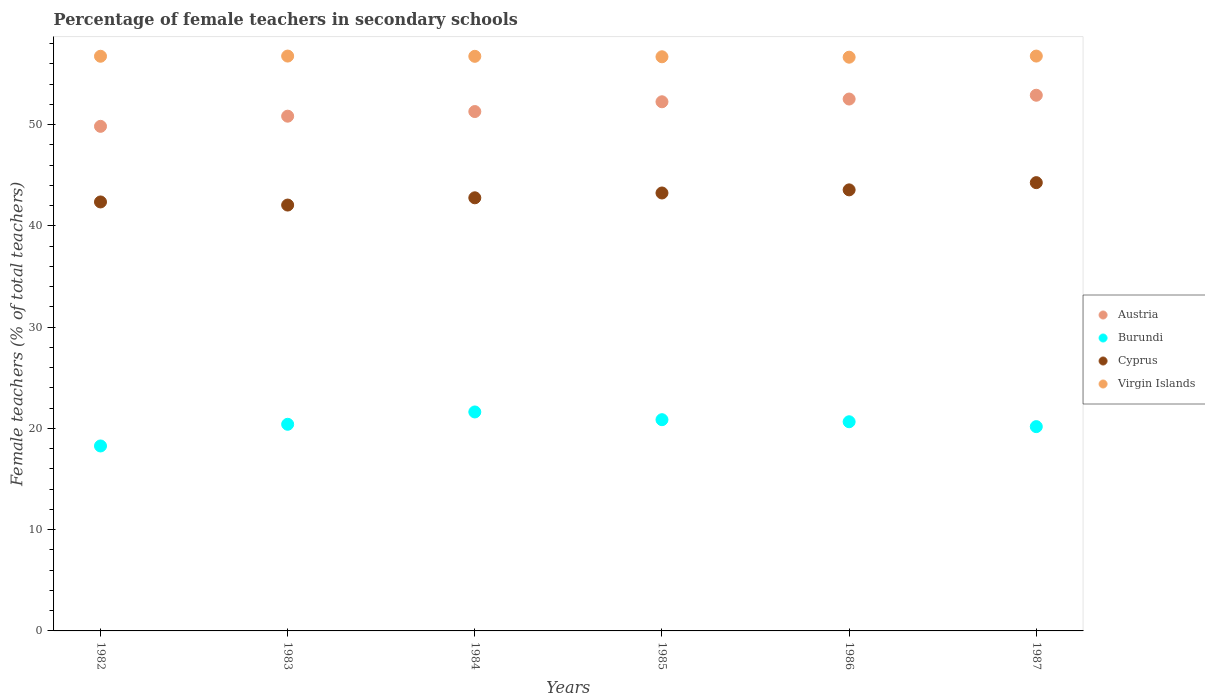Is the number of dotlines equal to the number of legend labels?
Offer a very short reply. Yes. What is the percentage of female teachers in Cyprus in 1983?
Offer a very short reply. 42.06. Across all years, what is the maximum percentage of female teachers in Austria?
Offer a terse response. 52.91. Across all years, what is the minimum percentage of female teachers in Austria?
Your answer should be very brief. 49.84. In which year was the percentage of female teachers in Cyprus minimum?
Your response must be concise. 1983. What is the total percentage of female teachers in Virgin Islands in the graph?
Make the answer very short. 340.45. What is the difference between the percentage of female teachers in Burundi in 1985 and that in 1987?
Your response must be concise. 0.69. What is the difference between the percentage of female teachers in Cyprus in 1986 and the percentage of female teachers in Virgin Islands in 1982?
Provide a succinct answer. -13.2. What is the average percentage of female teachers in Cyprus per year?
Ensure brevity in your answer.  43.05. In the year 1983, what is the difference between the percentage of female teachers in Burundi and percentage of female teachers in Austria?
Keep it short and to the point. -30.43. In how many years, is the percentage of female teachers in Virgin Islands greater than 54 %?
Give a very brief answer. 6. What is the difference between the highest and the second highest percentage of female teachers in Burundi?
Make the answer very short. 0.76. What is the difference between the highest and the lowest percentage of female teachers in Cyprus?
Your answer should be very brief. 2.21. In how many years, is the percentage of female teachers in Virgin Islands greater than the average percentage of female teachers in Virgin Islands taken over all years?
Give a very brief answer. 4. Is the sum of the percentage of female teachers in Austria in 1982 and 1983 greater than the maximum percentage of female teachers in Burundi across all years?
Offer a terse response. Yes. Is it the case that in every year, the sum of the percentage of female teachers in Austria and percentage of female teachers in Virgin Islands  is greater than the sum of percentage of female teachers in Burundi and percentage of female teachers in Cyprus?
Offer a very short reply. Yes. Does the percentage of female teachers in Cyprus monotonically increase over the years?
Offer a terse response. No. How many dotlines are there?
Provide a succinct answer. 4. How many years are there in the graph?
Your answer should be very brief. 6. What is the difference between two consecutive major ticks on the Y-axis?
Your answer should be compact. 10. Are the values on the major ticks of Y-axis written in scientific E-notation?
Your answer should be compact. No. Does the graph contain any zero values?
Offer a very short reply. No. Does the graph contain grids?
Offer a terse response. No. How many legend labels are there?
Your answer should be compact. 4. How are the legend labels stacked?
Give a very brief answer. Vertical. What is the title of the graph?
Your answer should be very brief. Percentage of female teachers in secondary schools. Does "Norway" appear as one of the legend labels in the graph?
Your answer should be very brief. No. What is the label or title of the Y-axis?
Provide a short and direct response. Female teachers (% of total teachers). What is the Female teachers (% of total teachers) in Austria in 1982?
Your answer should be very brief. 49.84. What is the Female teachers (% of total teachers) in Burundi in 1982?
Offer a very short reply. 18.27. What is the Female teachers (% of total teachers) in Cyprus in 1982?
Your answer should be compact. 42.37. What is the Female teachers (% of total teachers) in Virgin Islands in 1982?
Provide a short and direct response. 56.76. What is the Female teachers (% of total teachers) of Austria in 1983?
Give a very brief answer. 50.84. What is the Female teachers (% of total teachers) of Burundi in 1983?
Make the answer very short. 20.41. What is the Female teachers (% of total teachers) of Cyprus in 1983?
Offer a terse response. 42.06. What is the Female teachers (% of total teachers) in Virgin Islands in 1983?
Keep it short and to the point. 56.78. What is the Female teachers (% of total teachers) in Austria in 1984?
Ensure brevity in your answer.  51.3. What is the Female teachers (% of total teachers) of Burundi in 1984?
Your response must be concise. 21.63. What is the Female teachers (% of total teachers) in Cyprus in 1984?
Make the answer very short. 42.78. What is the Female teachers (% of total teachers) in Virgin Islands in 1984?
Offer a very short reply. 56.75. What is the Female teachers (% of total teachers) in Austria in 1985?
Ensure brevity in your answer.  52.26. What is the Female teachers (% of total teachers) in Burundi in 1985?
Give a very brief answer. 20.86. What is the Female teachers (% of total teachers) in Cyprus in 1985?
Offer a very short reply. 43.26. What is the Female teachers (% of total teachers) in Virgin Islands in 1985?
Offer a very short reply. 56.71. What is the Female teachers (% of total teachers) of Austria in 1986?
Make the answer very short. 52.53. What is the Female teachers (% of total teachers) in Burundi in 1986?
Provide a succinct answer. 20.66. What is the Female teachers (% of total teachers) in Cyprus in 1986?
Make the answer very short. 43.56. What is the Female teachers (% of total teachers) of Virgin Islands in 1986?
Keep it short and to the point. 56.67. What is the Female teachers (% of total teachers) of Austria in 1987?
Provide a succinct answer. 52.91. What is the Female teachers (% of total teachers) in Burundi in 1987?
Make the answer very short. 20.18. What is the Female teachers (% of total teachers) in Cyprus in 1987?
Provide a succinct answer. 44.28. What is the Female teachers (% of total teachers) in Virgin Islands in 1987?
Your answer should be compact. 56.78. Across all years, what is the maximum Female teachers (% of total teachers) of Austria?
Offer a terse response. 52.91. Across all years, what is the maximum Female teachers (% of total teachers) of Burundi?
Offer a terse response. 21.63. Across all years, what is the maximum Female teachers (% of total teachers) of Cyprus?
Offer a very short reply. 44.28. Across all years, what is the maximum Female teachers (% of total teachers) of Virgin Islands?
Your answer should be very brief. 56.78. Across all years, what is the minimum Female teachers (% of total teachers) in Austria?
Your answer should be very brief. 49.84. Across all years, what is the minimum Female teachers (% of total teachers) of Burundi?
Give a very brief answer. 18.27. Across all years, what is the minimum Female teachers (% of total teachers) of Cyprus?
Ensure brevity in your answer.  42.06. Across all years, what is the minimum Female teachers (% of total teachers) in Virgin Islands?
Your answer should be compact. 56.67. What is the total Female teachers (% of total teachers) of Austria in the graph?
Keep it short and to the point. 309.69. What is the total Female teachers (% of total teachers) of Burundi in the graph?
Your answer should be very brief. 122.01. What is the total Female teachers (% of total teachers) of Cyprus in the graph?
Keep it short and to the point. 258.31. What is the total Female teachers (% of total teachers) of Virgin Islands in the graph?
Provide a succinct answer. 340.45. What is the difference between the Female teachers (% of total teachers) of Austria in 1982 and that in 1983?
Ensure brevity in your answer.  -1. What is the difference between the Female teachers (% of total teachers) of Burundi in 1982 and that in 1983?
Your answer should be very brief. -2.14. What is the difference between the Female teachers (% of total teachers) in Cyprus in 1982 and that in 1983?
Keep it short and to the point. 0.31. What is the difference between the Female teachers (% of total teachers) of Virgin Islands in 1982 and that in 1983?
Offer a terse response. -0.02. What is the difference between the Female teachers (% of total teachers) of Austria in 1982 and that in 1984?
Your answer should be very brief. -1.46. What is the difference between the Female teachers (% of total teachers) in Burundi in 1982 and that in 1984?
Your response must be concise. -3.36. What is the difference between the Female teachers (% of total teachers) of Cyprus in 1982 and that in 1984?
Ensure brevity in your answer.  -0.41. What is the difference between the Female teachers (% of total teachers) in Virgin Islands in 1982 and that in 1984?
Ensure brevity in your answer.  0.01. What is the difference between the Female teachers (% of total teachers) of Austria in 1982 and that in 1985?
Provide a succinct answer. -2.43. What is the difference between the Female teachers (% of total teachers) of Burundi in 1982 and that in 1985?
Provide a short and direct response. -2.6. What is the difference between the Female teachers (% of total teachers) of Cyprus in 1982 and that in 1985?
Make the answer very short. -0.89. What is the difference between the Female teachers (% of total teachers) of Virgin Islands in 1982 and that in 1985?
Offer a terse response. 0.05. What is the difference between the Female teachers (% of total teachers) in Austria in 1982 and that in 1986?
Ensure brevity in your answer.  -2.7. What is the difference between the Female teachers (% of total teachers) of Burundi in 1982 and that in 1986?
Your answer should be very brief. -2.39. What is the difference between the Female teachers (% of total teachers) in Cyprus in 1982 and that in 1986?
Your answer should be very brief. -1.19. What is the difference between the Female teachers (% of total teachers) in Virgin Islands in 1982 and that in 1986?
Provide a succinct answer. 0.09. What is the difference between the Female teachers (% of total teachers) in Austria in 1982 and that in 1987?
Your answer should be compact. -3.07. What is the difference between the Female teachers (% of total teachers) in Burundi in 1982 and that in 1987?
Your response must be concise. -1.91. What is the difference between the Female teachers (% of total teachers) of Cyprus in 1982 and that in 1987?
Make the answer very short. -1.91. What is the difference between the Female teachers (% of total teachers) in Virgin Islands in 1982 and that in 1987?
Offer a very short reply. -0.02. What is the difference between the Female teachers (% of total teachers) of Austria in 1983 and that in 1984?
Your answer should be compact. -0.46. What is the difference between the Female teachers (% of total teachers) in Burundi in 1983 and that in 1984?
Ensure brevity in your answer.  -1.22. What is the difference between the Female teachers (% of total teachers) in Cyprus in 1983 and that in 1984?
Give a very brief answer. -0.72. What is the difference between the Female teachers (% of total teachers) of Virgin Islands in 1983 and that in 1984?
Provide a succinct answer. 0.03. What is the difference between the Female teachers (% of total teachers) of Austria in 1983 and that in 1985?
Provide a short and direct response. -1.42. What is the difference between the Female teachers (% of total teachers) in Burundi in 1983 and that in 1985?
Provide a short and direct response. -0.45. What is the difference between the Female teachers (% of total teachers) of Cyprus in 1983 and that in 1985?
Ensure brevity in your answer.  -1.19. What is the difference between the Female teachers (% of total teachers) of Virgin Islands in 1983 and that in 1985?
Your answer should be compact. 0.07. What is the difference between the Female teachers (% of total teachers) of Austria in 1983 and that in 1986?
Keep it short and to the point. -1.69. What is the difference between the Female teachers (% of total teachers) in Cyprus in 1983 and that in 1986?
Give a very brief answer. -1.5. What is the difference between the Female teachers (% of total teachers) in Virgin Islands in 1983 and that in 1986?
Keep it short and to the point. 0.11. What is the difference between the Female teachers (% of total teachers) of Austria in 1983 and that in 1987?
Keep it short and to the point. -2.07. What is the difference between the Female teachers (% of total teachers) in Burundi in 1983 and that in 1987?
Your response must be concise. 0.23. What is the difference between the Female teachers (% of total teachers) in Cyprus in 1983 and that in 1987?
Keep it short and to the point. -2.21. What is the difference between the Female teachers (% of total teachers) in Virgin Islands in 1983 and that in 1987?
Provide a succinct answer. 0. What is the difference between the Female teachers (% of total teachers) in Austria in 1984 and that in 1985?
Ensure brevity in your answer.  -0.96. What is the difference between the Female teachers (% of total teachers) of Burundi in 1984 and that in 1985?
Make the answer very short. 0.76. What is the difference between the Female teachers (% of total teachers) in Cyprus in 1984 and that in 1985?
Keep it short and to the point. -0.48. What is the difference between the Female teachers (% of total teachers) of Virgin Islands in 1984 and that in 1985?
Offer a terse response. 0.04. What is the difference between the Female teachers (% of total teachers) of Austria in 1984 and that in 1986?
Make the answer very short. -1.24. What is the difference between the Female teachers (% of total teachers) of Burundi in 1984 and that in 1986?
Provide a succinct answer. 0.97. What is the difference between the Female teachers (% of total teachers) of Cyprus in 1984 and that in 1986?
Provide a succinct answer. -0.78. What is the difference between the Female teachers (% of total teachers) in Virgin Islands in 1984 and that in 1986?
Provide a succinct answer. 0.09. What is the difference between the Female teachers (% of total teachers) in Austria in 1984 and that in 1987?
Make the answer very short. -1.61. What is the difference between the Female teachers (% of total teachers) of Burundi in 1984 and that in 1987?
Make the answer very short. 1.45. What is the difference between the Female teachers (% of total teachers) in Cyprus in 1984 and that in 1987?
Your answer should be compact. -1.5. What is the difference between the Female teachers (% of total teachers) in Virgin Islands in 1984 and that in 1987?
Give a very brief answer. -0.03. What is the difference between the Female teachers (% of total teachers) in Austria in 1985 and that in 1986?
Your answer should be very brief. -0.27. What is the difference between the Female teachers (% of total teachers) of Burundi in 1985 and that in 1986?
Provide a short and direct response. 0.2. What is the difference between the Female teachers (% of total teachers) in Cyprus in 1985 and that in 1986?
Provide a short and direct response. -0.31. What is the difference between the Female teachers (% of total teachers) of Virgin Islands in 1985 and that in 1986?
Give a very brief answer. 0.04. What is the difference between the Female teachers (% of total teachers) of Austria in 1985 and that in 1987?
Ensure brevity in your answer.  -0.65. What is the difference between the Female teachers (% of total teachers) of Burundi in 1985 and that in 1987?
Make the answer very short. 0.69. What is the difference between the Female teachers (% of total teachers) in Cyprus in 1985 and that in 1987?
Make the answer very short. -1.02. What is the difference between the Female teachers (% of total teachers) in Virgin Islands in 1985 and that in 1987?
Your answer should be compact. -0.07. What is the difference between the Female teachers (% of total teachers) of Austria in 1986 and that in 1987?
Give a very brief answer. -0.38. What is the difference between the Female teachers (% of total teachers) of Burundi in 1986 and that in 1987?
Ensure brevity in your answer.  0.48. What is the difference between the Female teachers (% of total teachers) in Cyprus in 1986 and that in 1987?
Your answer should be compact. -0.71. What is the difference between the Female teachers (% of total teachers) of Virgin Islands in 1986 and that in 1987?
Ensure brevity in your answer.  -0.11. What is the difference between the Female teachers (% of total teachers) of Austria in 1982 and the Female teachers (% of total teachers) of Burundi in 1983?
Make the answer very short. 29.43. What is the difference between the Female teachers (% of total teachers) of Austria in 1982 and the Female teachers (% of total teachers) of Cyprus in 1983?
Your response must be concise. 7.78. What is the difference between the Female teachers (% of total teachers) of Austria in 1982 and the Female teachers (% of total teachers) of Virgin Islands in 1983?
Ensure brevity in your answer.  -6.94. What is the difference between the Female teachers (% of total teachers) in Burundi in 1982 and the Female teachers (% of total teachers) in Cyprus in 1983?
Give a very brief answer. -23.79. What is the difference between the Female teachers (% of total teachers) of Burundi in 1982 and the Female teachers (% of total teachers) of Virgin Islands in 1983?
Make the answer very short. -38.51. What is the difference between the Female teachers (% of total teachers) in Cyprus in 1982 and the Female teachers (% of total teachers) in Virgin Islands in 1983?
Offer a very short reply. -14.41. What is the difference between the Female teachers (% of total teachers) in Austria in 1982 and the Female teachers (% of total teachers) in Burundi in 1984?
Offer a terse response. 28.21. What is the difference between the Female teachers (% of total teachers) of Austria in 1982 and the Female teachers (% of total teachers) of Cyprus in 1984?
Provide a succinct answer. 7.06. What is the difference between the Female teachers (% of total teachers) in Austria in 1982 and the Female teachers (% of total teachers) in Virgin Islands in 1984?
Provide a succinct answer. -6.92. What is the difference between the Female teachers (% of total teachers) of Burundi in 1982 and the Female teachers (% of total teachers) of Cyprus in 1984?
Offer a terse response. -24.51. What is the difference between the Female teachers (% of total teachers) in Burundi in 1982 and the Female teachers (% of total teachers) in Virgin Islands in 1984?
Make the answer very short. -38.48. What is the difference between the Female teachers (% of total teachers) of Cyprus in 1982 and the Female teachers (% of total teachers) of Virgin Islands in 1984?
Offer a very short reply. -14.38. What is the difference between the Female teachers (% of total teachers) in Austria in 1982 and the Female teachers (% of total teachers) in Burundi in 1985?
Offer a terse response. 28.97. What is the difference between the Female teachers (% of total teachers) of Austria in 1982 and the Female teachers (% of total teachers) of Cyprus in 1985?
Give a very brief answer. 6.58. What is the difference between the Female teachers (% of total teachers) of Austria in 1982 and the Female teachers (% of total teachers) of Virgin Islands in 1985?
Keep it short and to the point. -6.87. What is the difference between the Female teachers (% of total teachers) in Burundi in 1982 and the Female teachers (% of total teachers) in Cyprus in 1985?
Ensure brevity in your answer.  -24.99. What is the difference between the Female teachers (% of total teachers) in Burundi in 1982 and the Female teachers (% of total teachers) in Virgin Islands in 1985?
Make the answer very short. -38.44. What is the difference between the Female teachers (% of total teachers) of Cyprus in 1982 and the Female teachers (% of total teachers) of Virgin Islands in 1985?
Offer a terse response. -14.34. What is the difference between the Female teachers (% of total teachers) in Austria in 1982 and the Female teachers (% of total teachers) in Burundi in 1986?
Your answer should be very brief. 29.18. What is the difference between the Female teachers (% of total teachers) in Austria in 1982 and the Female teachers (% of total teachers) in Cyprus in 1986?
Ensure brevity in your answer.  6.28. What is the difference between the Female teachers (% of total teachers) of Austria in 1982 and the Female teachers (% of total teachers) of Virgin Islands in 1986?
Offer a very short reply. -6.83. What is the difference between the Female teachers (% of total teachers) in Burundi in 1982 and the Female teachers (% of total teachers) in Cyprus in 1986?
Offer a very short reply. -25.29. What is the difference between the Female teachers (% of total teachers) of Burundi in 1982 and the Female teachers (% of total teachers) of Virgin Islands in 1986?
Offer a very short reply. -38.4. What is the difference between the Female teachers (% of total teachers) of Cyprus in 1982 and the Female teachers (% of total teachers) of Virgin Islands in 1986?
Offer a very short reply. -14.3. What is the difference between the Female teachers (% of total teachers) of Austria in 1982 and the Female teachers (% of total teachers) of Burundi in 1987?
Keep it short and to the point. 29.66. What is the difference between the Female teachers (% of total teachers) of Austria in 1982 and the Female teachers (% of total teachers) of Cyprus in 1987?
Your answer should be very brief. 5.56. What is the difference between the Female teachers (% of total teachers) in Austria in 1982 and the Female teachers (% of total teachers) in Virgin Islands in 1987?
Provide a short and direct response. -6.94. What is the difference between the Female teachers (% of total teachers) in Burundi in 1982 and the Female teachers (% of total teachers) in Cyprus in 1987?
Offer a terse response. -26.01. What is the difference between the Female teachers (% of total teachers) of Burundi in 1982 and the Female teachers (% of total teachers) of Virgin Islands in 1987?
Provide a succinct answer. -38.51. What is the difference between the Female teachers (% of total teachers) of Cyprus in 1982 and the Female teachers (% of total teachers) of Virgin Islands in 1987?
Provide a short and direct response. -14.41. What is the difference between the Female teachers (% of total teachers) of Austria in 1983 and the Female teachers (% of total teachers) of Burundi in 1984?
Ensure brevity in your answer.  29.21. What is the difference between the Female teachers (% of total teachers) in Austria in 1983 and the Female teachers (% of total teachers) in Cyprus in 1984?
Your answer should be compact. 8.06. What is the difference between the Female teachers (% of total teachers) of Austria in 1983 and the Female teachers (% of total teachers) of Virgin Islands in 1984?
Provide a succinct answer. -5.91. What is the difference between the Female teachers (% of total teachers) in Burundi in 1983 and the Female teachers (% of total teachers) in Cyprus in 1984?
Ensure brevity in your answer.  -22.37. What is the difference between the Female teachers (% of total teachers) of Burundi in 1983 and the Female teachers (% of total teachers) of Virgin Islands in 1984?
Offer a terse response. -36.34. What is the difference between the Female teachers (% of total teachers) in Cyprus in 1983 and the Female teachers (% of total teachers) in Virgin Islands in 1984?
Your answer should be very brief. -14.69. What is the difference between the Female teachers (% of total teachers) of Austria in 1983 and the Female teachers (% of total teachers) of Burundi in 1985?
Provide a succinct answer. 29.98. What is the difference between the Female teachers (% of total teachers) in Austria in 1983 and the Female teachers (% of total teachers) in Cyprus in 1985?
Provide a succinct answer. 7.59. What is the difference between the Female teachers (% of total teachers) of Austria in 1983 and the Female teachers (% of total teachers) of Virgin Islands in 1985?
Provide a short and direct response. -5.87. What is the difference between the Female teachers (% of total teachers) in Burundi in 1983 and the Female teachers (% of total teachers) in Cyprus in 1985?
Offer a very short reply. -22.85. What is the difference between the Female teachers (% of total teachers) in Burundi in 1983 and the Female teachers (% of total teachers) in Virgin Islands in 1985?
Make the answer very short. -36.3. What is the difference between the Female teachers (% of total teachers) of Cyprus in 1983 and the Female teachers (% of total teachers) of Virgin Islands in 1985?
Offer a terse response. -14.65. What is the difference between the Female teachers (% of total teachers) in Austria in 1983 and the Female teachers (% of total teachers) in Burundi in 1986?
Offer a terse response. 30.18. What is the difference between the Female teachers (% of total teachers) in Austria in 1983 and the Female teachers (% of total teachers) in Cyprus in 1986?
Ensure brevity in your answer.  7.28. What is the difference between the Female teachers (% of total teachers) in Austria in 1983 and the Female teachers (% of total teachers) in Virgin Islands in 1986?
Provide a short and direct response. -5.83. What is the difference between the Female teachers (% of total teachers) in Burundi in 1983 and the Female teachers (% of total teachers) in Cyprus in 1986?
Keep it short and to the point. -23.15. What is the difference between the Female teachers (% of total teachers) in Burundi in 1983 and the Female teachers (% of total teachers) in Virgin Islands in 1986?
Keep it short and to the point. -36.26. What is the difference between the Female teachers (% of total teachers) of Cyprus in 1983 and the Female teachers (% of total teachers) of Virgin Islands in 1986?
Offer a very short reply. -14.6. What is the difference between the Female teachers (% of total teachers) of Austria in 1983 and the Female teachers (% of total teachers) of Burundi in 1987?
Provide a succinct answer. 30.66. What is the difference between the Female teachers (% of total teachers) of Austria in 1983 and the Female teachers (% of total teachers) of Cyprus in 1987?
Provide a short and direct response. 6.56. What is the difference between the Female teachers (% of total teachers) in Austria in 1983 and the Female teachers (% of total teachers) in Virgin Islands in 1987?
Ensure brevity in your answer.  -5.94. What is the difference between the Female teachers (% of total teachers) in Burundi in 1983 and the Female teachers (% of total teachers) in Cyprus in 1987?
Offer a terse response. -23.87. What is the difference between the Female teachers (% of total teachers) of Burundi in 1983 and the Female teachers (% of total teachers) of Virgin Islands in 1987?
Your answer should be very brief. -36.37. What is the difference between the Female teachers (% of total teachers) of Cyprus in 1983 and the Female teachers (% of total teachers) of Virgin Islands in 1987?
Provide a short and direct response. -14.72. What is the difference between the Female teachers (% of total teachers) of Austria in 1984 and the Female teachers (% of total teachers) of Burundi in 1985?
Your response must be concise. 30.44. What is the difference between the Female teachers (% of total teachers) of Austria in 1984 and the Female teachers (% of total teachers) of Cyprus in 1985?
Your answer should be very brief. 8.04. What is the difference between the Female teachers (% of total teachers) in Austria in 1984 and the Female teachers (% of total teachers) in Virgin Islands in 1985?
Offer a very short reply. -5.41. What is the difference between the Female teachers (% of total teachers) in Burundi in 1984 and the Female teachers (% of total teachers) in Cyprus in 1985?
Make the answer very short. -21.63. What is the difference between the Female teachers (% of total teachers) in Burundi in 1984 and the Female teachers (% of total teachers) in Virgin Islands in 1985?
Give a very brief answer. -35.08. What is the difference between the Female teachers (% of total teachers) of Cyprus in 1984 and the Female teachers (% of total teachers) of Virgin Islands in 1985?
Offer a terse response. -13.93. What is the difference between the Female teachers (% of total teachers) in Austria in 1984 and the Female teachers (% of total teachers) in Burundi in 1986?
Your answer should be compact. 30.64. What is the difference between the Female teachers (% of total teachers) of Austria in 1984 and the Female teachers (% of total teachers) of Cyprus in 1986?
Your answer should be compact. 7.74. What is the difference between the Female teachers (% of total teachers) of Austria in 1984 and the Female teachers (% of total teachers) of Virgin Islands in 1986?
Provide a succinct answer. -5.37. What is the difference between the Female teachers (% of total teachers) in Burundi in 1984 and the Female teachers (% of total teachers) in Cyprus in 1986?
Your response must be concise. -21.94. What is the difference between the Female teachers (% of total teachers) of Burundi in 1984 and the Female teachers (% of total teachers) of Virgin Islands in 1986?
Your answer should be very brief. -35.04. What is the difference between the Female teachers (% of total teachers) in Cyprus in 1984 and the Female teachers (% of total teachers) in Virgin Islands in 1986?
Keep it short and to the point. -13.89. What is the difference between the Female teachers (% of total teachers) in Austria in 1984 and the Female teachers (% of total teachers) in Burundi in 1987?
Your response must be concise. 31.12. What is the difference between the Female teachers (% of total teachers) in Austria in 1984 and the Female teachers (% of total teachers) in Cyprus in 1987?
Offer a very short reply. 7.02. What is the difference between the Female teachers (% of total teachers) of Austria in 1984 and the Female teachers (% of total teachers) of Virgin Islands in 1987?
Your response must be concise. -5.48. What is the difference between the Female teachers (% of total teachers) of Burundi in 1984 and the Female teachers (% of total teachers) of Cyprus in 1987?
Ensure brevity in your answer.  -22.65. What is the difference between the Female teachers (% of total teachers) of Burundi in 1984 and the Female teachers (% of total teachers) of Virgin Islands in 1987?
Your answer should be compact. -35.15. What is the difference between the Female teachers (% of total teachers) of Cyprus in 1984 and the Female teachers (% of total teachers) of Virgin Islands in 1987?
Keep it short and to the point. -14. What is the difference between the Female teachers (% of total teachers) in Austria in 1985 and the Female teachers (% of total teachers) in Burundi in 1986?
Make the answer very short. 31.6. What is the difference between the Female teachers (% of total teachers) of Austria in 1985 and the Female teachers (% of total teachers) of Cyprus in 1986?
Give a very brief answer. 8.7. What is the difference between the Female teachers (% of total teachers) in Austria in 1985 and the Female teachers (% of total teachers) in Virgin Islands in 1986?
Make the answer very short. -4.4. What is the difference between the Female teachers (% of total teachers) in Burundi in 1985 and the Female teachers (% of total teachers) in Cyprus in 1986?
Your answer should be very brief. -22.7. What is the difference between the Female teachers (% of total teachers) in Burundi in 1985 and the Female teachers (% of total teachers) in Virgin Islands in 1986?
Make the answer very short. -35.8. What is the difference between the Female teachers (% of total teachers) in Cyprus in 1985 and the Female teachers (% of total teachers) in Virgin Islands in 1986?
Keep it short and to the point. -13.41. What is the difference between the Female teachers (% of total teachers) in Austria in 1985 and the Female teachers (% of total teachers) in Burundi in 1987?
Offer a terse response. 32.09. What is the difference between the Female teachers (% of total teachers) in Austria in 1985 and the Female teachers (% of total teachers) in Cyprus in 1987?
Give a very brief answer. 7.99. What is the difference between the Female teachers (% of total teachers) in Austria in 1985 and the Female teachers (% of total teachers) in Virgin Islands in 1987?
Your answer should be compact. -4.51. What is the difference between the Female teachers (% of total teachers) in Burundi in 1985 and the Female teachers (% of total teachers) in Cyprus in 1987?
Offer a very short reply. -23.41. What is the difference between the Female teachers (% of total teachers) in Burundi in 1985 and the Female teachers (% of total teachers) in Virgin Islands in 1987?
Keep it short and to the point. -35.91. What is the difference between the Female teachers (% of total teachers) of Cyprus in 1985 and the Female teachers (% of total teachers) of Virgin Islands in 1987?
Give a very brief answer. -13.52. What is the difference between the Female teachers (% of total teachers) of Austria in 1986 and the Female teachers (% of total teachers) of Burundi in 1987?
Your response must be concise. 32.36. What is the difference between the Female teachers (% of total teachers) of Austria in 1986 and the Female teachers (% of total teachers) of Cyprus in 1987?
Offer a very short reply. 8.26. What is the difference between the Female teachers (% of total teachers) in Austria in 1986 and the Female teachers (% of total teachers) in Virgin Islands in 1987?
Offer a terse response. -4.24. What is the difference between the Female teachers (% of total teachers) in Burundi in 1986 and the Female teachers (% of total teachers) in Cyprus in 1987?
Give a very brief answer. -23.62. What is the difference between the Female teachers (% of total teachers) of Burundi in 1986 and the Female teachers (% of total teachers) of Virgin Islands in 1987?
Offer a terse response. -36.12. What is the difference between the Female teachers (% of total teachers) of Cyprus in 1986 and the Female teachers (% of total teachers) of Virgin Islands in 1987?
Your answer should be compact. -13.22. What is the average Female teachers (% of total teachers) of Austria per year?
Your response must be concise. 51.61. What is the average Female teachers (% of total teachers) of Burundi per year?
Your response must be concise. 20.33. What is the average Female teachers (% of total teachers) in Cyprus per year?
Your answer should be very brief. 43.05. What is the average Female teachers (% of total teachers) of Virgin Islands per year?
Provide a succinct answer. 56.74. In the year 1982, what is the difference between the Female teachers (% of total teachers) in Austria and Female teachers (% of total teachers) in Burundi?
Provide a short and direct response. 31.57. In the year 1982, what is the difference between the Female teachers (% of total teachers) of Austria and Female teachers (% of total teachers) of Cyprus?
Your response must be concise. 7.47. In the year 1982, what is the difference between the Female teachers (% of total teachers) of Austria and Female teachers (% of total teachers) of Virgin Islands?
Ensure brevity in your answer.  -6.92. In the year 1982, what is the difference between the Female teachers (% of total teachers) in Burundi and Female teachers (% of total teachers) in Cyprus?
Your answer should be very brief. -24.1. In the year 1982, what is the difference between the Female teachers (% of total teachers) in Burundi and Female teachers (% of total teachers) in Virgin Islands?
Provide a short and direct response. -38.49. In the year 1982, what is the difference between the Female teachers (% of total teachers) in Cyprus and Female teachers (% of total teachers) in Virgin Islands?
Provide a succinct answer. -14.39. In the year 1983, what is the difference between the Female teachers (% of total teachers) in Austria and Female teachers (% of total teachers) in Burundi?
Make the answer very short. 30.43. In the year 1983, what is the difference between the Female teachers (% of total teachers) of Austria and Female teachers (% of total teachers) of Cyprus?
Your answer should be very brief. 8.78. In the year 1983, what is the difference between the Female teachers (% of total teachers) in Austria and Female teachers (% of total teachers) in Virgin Islands?
Your answer should be compact. -5.94. In the year 1983, what is the difference between the Female teachers (% of total teachers) of Burundi and Female teachers (% of total teachers) of Cyprus?
Make the answer very short. -21.65. In the year 1983, what is the difference between the Female teachers (% of total teachers) in Burundi and Female teachers (% of total teachers) in Virgin Islands?
Your response must be concise. -36.37. In the year 1983, what is the difference between the Female teachers (% of total teachers) of Cyprus and Female teachers (% of total teachers) of Virgin Islands?
Keep it short and to the point. -14.72. In the year 1984, what is the difference between the Female teachers (% of total teachers) in Austria and Female teachers (% of total teachers) in Burundi?
Provide a succinct answer. 29.67. In the year 1984, what is the difference between the Female teachers (% of total teachers) in Austria and Female teachers (% of total teachers) in Cyprus?
Ensure brevity in your answer.  8.52. In the year 1984, what is the difference between the Female teachers (% of total teachers) in Austria and Female teachers (% of total teachers) in Virgin Islands?
Offer a very short reply. -5.45. In the year 1984, what is the difference between the Female teachers (% of total teachers) of Burundi and Female teachers (% of total teachers) of Cyprus?
Give a very brief answer. -21.15. In the year 1984, what is the difference between the Female teachers (% of total teachers) of Burundi and Female teachers (% of total teachers) of Virgin Islands?
Offer a terse response. -35.13. In the year 1984, what is the difference between the Female teachers (% of total teachers) in Cyprus and Female teachers (% of total teachers) in Virgin Islands?
Provide a short and direct response. -13.97. In the year 1985, what is the difference between the Female teachers (% of total teachers) of Austria and Female teachers (% of total teachers) of Burundi?
Provide a short and direct response. 31.4. In the year 1985, what is the difference between the Female teachers (% of total teachers) in Austria and Female teachers (% of total teachers) in Cyprus?
Give a very brief answer. 9.01. In the year 1985, what is the difference between the Female teachers (% of total teachers) of Austria and Female teachers (% of total teachers) of Virgin Islands?
Your answer should be compact. -4.45. In the year 1985, what is the difference between the Female teachers (% of total teachers) in Burundi and Female teachers (% of total teachers) in Cyprus?
Keep it short and to the point. -22.39. In the year 1985, what is the difference between the Female teachers (% of total teachers) of Burundi and Female teachers (% of total teachers) of Virgin Islands?
Give a very brief answer. -35.85. In the year 1985, what is the difference between the Female teachers (% of total teachers) of Cyprus and Female teachers (% of total teachers) of Virgin Islands?
Provide a succinct answer. -13.45. In the year 1986, what is the difference between the Female teachers (% of total teachers) in Austria and Female teachers (% of total teachers) in Burundi?
Provide a succinct answer. 31.87. In the year 1986, what is the difference between the Female teachers (% of total teachers) of Austria and Female teachers (% of total teachers) of Cyprus?
Provide a short and direct response. 8.97. In the year 1986, what is the difference between the Female teachers (% of total teachers) in Austria and Female teachers (% of total teachers) in Virgin Islands?
Give a very brief answer. -4.13. In the year 1986, what is the difference between the Female teachers (% of total teachers) in Burundi and Female teachers (% of total teachers) in Cyprus?
Keep it short and to the point. -22.9. In the year 1986, what is the difference between the Female teachers (% of total teachers) in Burundi and Female teachers (% of total teachers) in Virgin Islands?
Offer a very short reply. -36.01. In the year 1986, what is the difference between the Female teachers (% of total teachers) in Cyprus and Female teachers (% of total teachers) in Virgin Islands?
Provide a short and direct response. -13.1. In the year 1987, what is the difference between the Female teachers (% of total teachers) of Austria and Female teachers (% of total teachers) of Burundi?
Provide a short and direct response. 32.73. In the year 1987, what is the difference between the Female teachers (% of total teachers) of Austria and Female teachers (% of total teachers) of Cyprus?
Provide a succinct answer. 8.63. In the year 1987, what is the difference between the Female teachers (% of total teachers) in Austria and Female teachers (% of total teachers) in Virgin Islands?
Offer a terse response. -3.87. In the year 1987, what is the difference between the Female teachers (% of total teachers) in Burundi and Female teachers (% of total teachers) in Cyprus?
Provide a succinct answer. -24.1. In the year 1987, what is the difference between the Female teachers (% of total teachers) of Burundi and Female teachers (% of total teachers) of Virgin Islands?
Keep it short and to the point. -36.6. In the year 1987, what is the difference between the Female teachers (% of total teachers) in Cyprus and Female teachers (% of total teachers) in Virgin Islands?
Keep it short and to the point. -12.5. What is the ratio of the Female teachers (% of total teachers) of Austria in 1982 to that in 1983?
Provide a short and direct response. 0.98. What is the ratio of the Female teachers (% of total teachers) in Burundi in 1982 to that in 1983?
Offer a terse response. 0.9. What is the ratio of the Female teachers (% of total teachers) in Cyprus in 1982 to that in 1983?
Keep it short and to the point. 1.01. What is the ratio of the Female teachers (% of total teachers) of Virgin Islands in 1982 to that in 1983?
Provide a succinct answer. 1. What is the ratio of the Female teachers (% of total teachers) of Austria in 1982 to that in 1984?
Your answer should be compact. 0.97. What is the ratio of the Female teachers (% of total teachers) in Burundi in 1982 to that in 1984?
Your answer should be compact. 0.84. What is the ratio of the Female teachers (% of total teachers) of Virgin Islands in 1982 to that in 1984?
Your answer should be very brief. 1. What is the ratio of the Female teachers (% of total teachers) of Austria in 1982 to that in 1985?
Your answer should be compact. 0.95. What is the ratio of the Female teachers (% of total teachers) in Burundi in 1982 to that in 1985?
Ensure brevity in your answer.  0.88. What is the ratio of the Female teachers (% of total teachers) in Cyprus in 1982 to that in 1985?
Provide a succinct answer. 0.98. What is the ratio of the Female teachers (% of total teachers) of Austria in 1982 to that in 1986?
Keep it short and to the point. 0.95. What is the ratio of the Female teachers (% of total teachers) of Burundi in 1982 to that in 1986?
Keep it short and to the point. 0.88. What is the ratio of the Female teachers (% of total teachers) of Cyprus in 1982 to that in 1986?
Make the answer very short. 0.97. What is the ratio of the Female teachers (% of total teachers) in Austria in 1982 to that in 1987?
Give a very brief answer. 0.94. What is the ratio of the Female teachers (% of total teachers) in Burundi in 1982 to that in 1987?
Provide a succinct answer. 0.91. What is the ratio of the Female teachers (% of total teachers) in Cyprus in 1982 to that in 1987?
Provide a succinct answer. 0.96. What is the ratio of the Female teachers (% of total teachers) in Burundi in 1983 to that in 1984?
Your answer should be compact. 0.94. What is the ratio of the Female teachers (% of total teachers) in Cyprus in 1983 to that in 1984?
Provide a short and direct response. 0.98. What is the ratio of the Female teachers (% of total teachers) of Austria in 1983 to that in 1985?
Keep it short and to the point. 0.97. What is the ratio of the Female teachers (% of total teachers) of Burundi in 1983 to that in 1985?
Keep it short and to the point. 0.98. What is the ratio of the Female teachers (% of total teachers) of Cyprus in 1983 to that in 1985?
Your answer should be compact. 0.97. What is the ratio of the Female teachers (% of total teachers) of Austria in 1983 to that in 1986?
Provide a succinct answer. 0.97. What is the ratio of the Female teachers (% of total teachers) in Burundi in 1983 to that in 1986?
Ensure brevity in your answer.  0.99. What is the ratio of the Female teachers (% of total teachers) in Cyprus in 1983 to that in 1986?
Ensure brevity in your answer.  0.97. What is the ratio of the Female teachers (% of total teachers) of Virgin Islands in 1983 to that in 1986?
Your response must be concise. 1. What is the ratio of the Female teachers (% of total teachers) of Austria in 1983 to that in 1987?
Ensure brevity in your answer.  0.96. What is the ratio of the Female teachers (% of total teachers) in Burundi in 1983 to that in 1987?
Make the answer very short. 1.01. What is the ratio of the Female teachers (% of total teachers) in Austria in 1984 to that in 1985?
Offer a very short reply. 0.98. What is the ratio of the Female teachers (% of total teachers) of Burundi in 1984 to that in 1985?
Offer a very short reply. 1.04. What is the ratio of the Female teachers (% of total teachers) in Cyprus in 1984 to that in 1985?
Keep it short and to the point. 0.99. What is the ratio of the Female teachers (% of total teachers) of Virgin Islands in 1984 to that in 1985?
Offer a very short reply. 1. What is the ratio of the Female teachers (% of total teachers) in Austria in 1984 to that in 1986?
Your answer should be compact. 0.98. What is the ratio of the Female teachers (% of total teachers) in Burundi in 1984 to that in 1986?
Offer a very short reply. 1.05. What is the ratio of the Female teachers (% of total teachers) of Virgin Islands in 1984 to that in 1986?
Offer a very short reply. 1. What is the ratio of the Female teachers (% of total teachers) in Austria in 1984 to that in 1987?
Your answer should be compact. 0.97. What is the ratio of the Female teachers (% of total teachers) of Burundi in 1984 to that in 1987?
Provide a succinct answer. 1.07. What is the ratio of the Female teachers (% of total teachers) of Cyprus in 1984 to that in 1987?
Keep it short and to the point. 0.97. What is the ratio of the Female teachers (% of total teachers) of Virgin Islands in 1984 to that in 1987?
Offer a terse response. 1. What is the ratio of the Female teachers (% of total teachers) in Austria in 1985 to that in 1986?
Your response must be concise. 0.99. What is the ratio of the Female teachers (% of total teachers) of Burundi in 1985 to that in 1986?
Provide a short and direct response. 1.01. What is the ratio of the Female teachers (% of total teachers) of Cyprus in 1985 to that in 1986?
Provide a succinct answer. 0.99. What is the ratio of the Female teachers (% of total teachers) in Virgin Islands in 1985 to that in 1986?
Ensure brevity in your answer.  1. What is the ratio of the Female teachers (% of total teachers) of Austria in 1985 to that in 1987?
Give a very brief answer. 0.99. What is the ratio of the Female teachers (% of total teachers) in Burundi in 1985 to that in 1987?
Your answer should be very brief. 1.03. What is the ratio of the Female teachers (% of total teachers) in Cyprus in 1985 to that in 1987?
Make the answer very short. 0.98. What is the ratio of the Female teachers (% of total teachers) in Austria in 1986 to that in 1987?
Your answer should be compact. 0.99. What is the ratio of the Female teachers (% of total teachers) in Burundi in 1986 to that in 1987?
Ensure brevity in your answer.  1.02. What is the ratio of the Female teachers (% of total teachers) of Cyprus in 1986 to that in 1987?
Give a very brief answer. 0.98. What is the difference between the highest and the second highest Female teachers (% of total teachers) in Austria?
Ensure brevity in your answer.  0.38. What is the difference between the highest and the second highest Female teachers (% of total teachers) in Burundi?
Provide a succinct answer. 0.76. What is the difference between the highest and the second highest Female teachers (% of total teachers) of Cyprus?
Ensure brevity in your answer.  0.71. What is the difference between the highest and the lowest Female teachers (% of total teachers) in Austria?
Offer a very short reply. 3.07. What is the difference between the highest and the lowest Female teachers (% of total teachers) of Burundi?
Ensure brevity in your answer.  3.36. What is the difference between the highest and the lowest Female teachers (% of total teachers) in Cyprus?
Offer a very short reply. 2.21. What is the difference between the highest and the lowest Female teachers (% of total teachers) of Virgin Islands?
Your answer should be very brief. 0.11. 